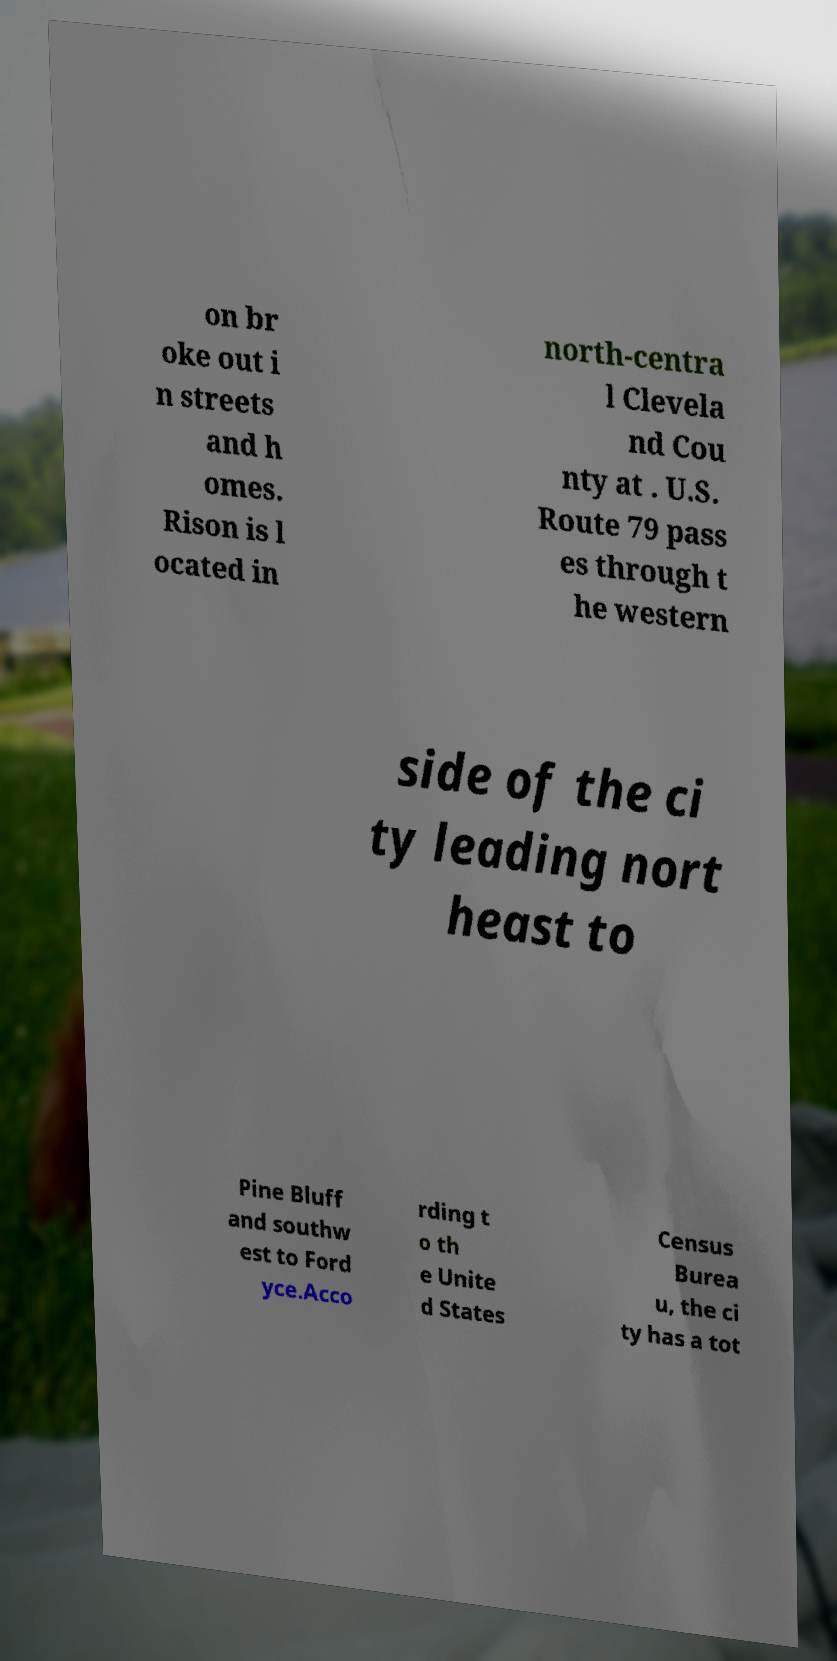For documentation purposes, I need the text within this image transcribed. Could you provide that? on br oke out i n streets and h omes. Rison is l ocated in north-centra l Clevela nd Cou nty at . U.S. Route 79 pass es through t he western side of the ci ty leading nort heast to Pine Bluff and southw est to Ford yce.Acco rding t o th e Unite d States Census Burea u, the ci ty has a tot 